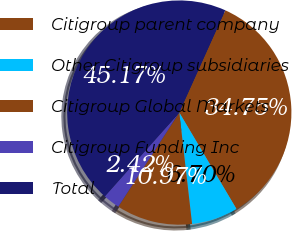<chart> <loc_0><loc_0><loc_500><loc_500><pie_chart><fcel>Citigroup parent company<fcel>Other Citigroup subsidiaries<fcel>Citigroup Global Markets<fcel>Citigroup Funding Inc<fcel>Total<nl><fcel>34.75%<fcel>6.7%<fcel>10.97%<fcel>2.42%<fcel>45.17%<nl></chart> 